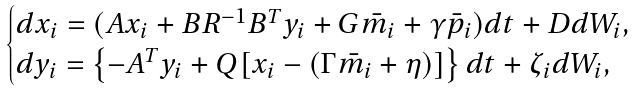Convert formula to latex. <formula><loc_0><loc_0><loc_500><loc_500>\begin{cases} d x _ { i } = ( A x _ { i } + B R ^ { - 1 } B ^ { T } y _ { i } + G \bar { m } _ { i } + \gamma \bar { p } _ { i } ) d t + D d W _ { i } , \\ d y _ { i } = \left \{ - A ^ { T } y _ { i } + Q [ x _ { i } - ( \Gamma \bar { m } _ { i } + \eta ) ] \right \} d t + \zeta _ { i } d W _ { i } , \end{cases}</formula> 